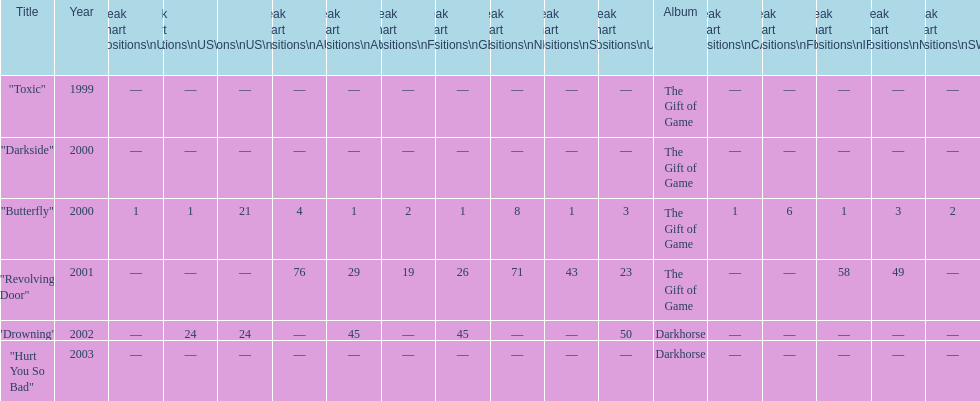How many singles have a ranking of 1 under ger? 1. 